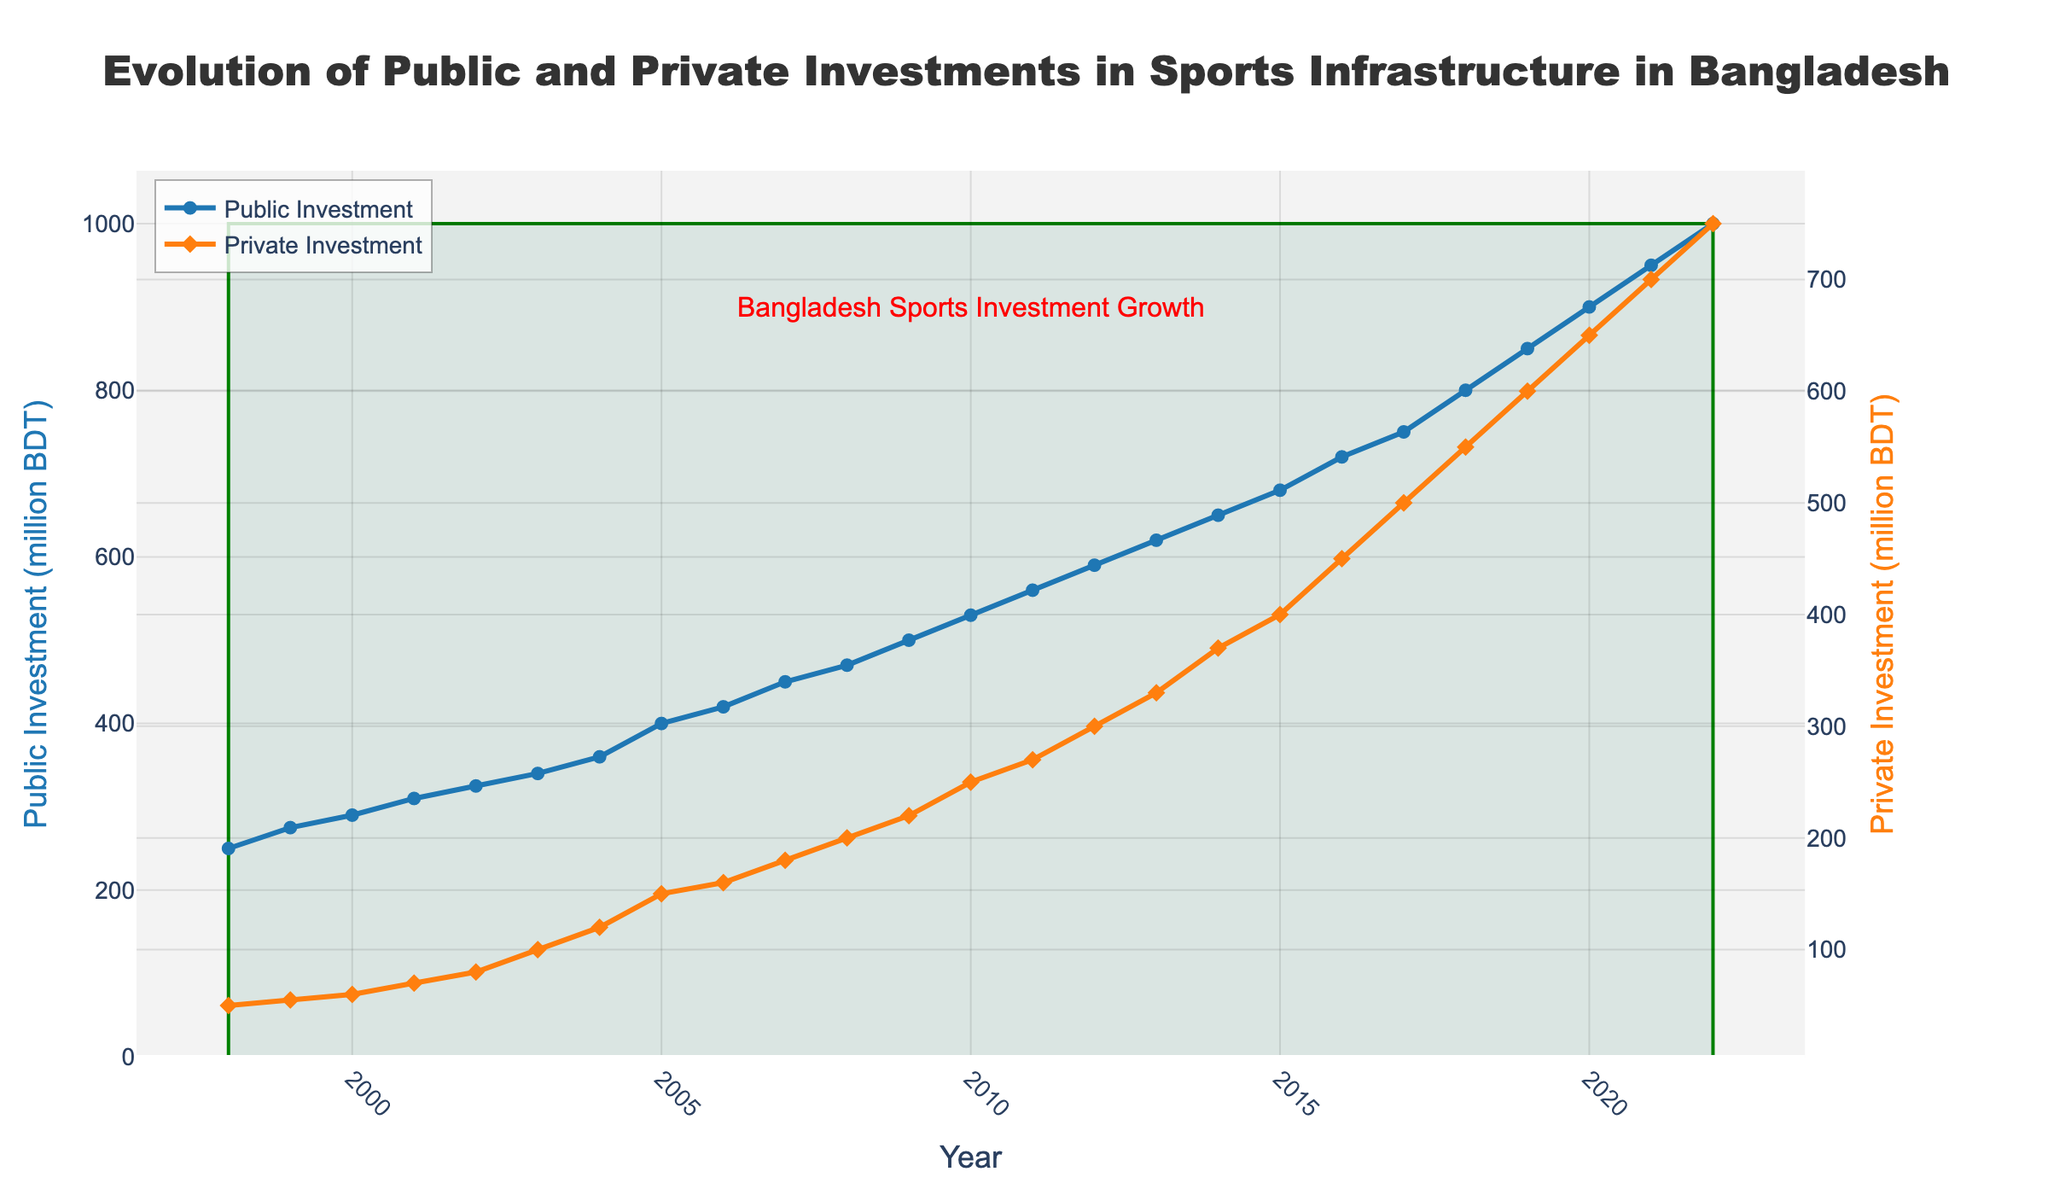what is the title of the plot? The title is prominently displayed at the top of the plot. The text reads "Evolution of Public and Private Investments in Sports Infrastructure in Bangladesh".
Answer: Evolution of Public and Private Investments in Sports Infrastructure in Bangladesh How many years does the x-axis of the plot cover? The x-axis starts at 1998 and ends at 2022. Counting all the years inclusive, it represents a span of 25 years.
Answer: 25 years What is the y-axis range for public investments? The y-axis for public investments starts at 0 million BDT and goes up to 1000 million BDT, as indicated by the axis labels.
Answer: 0 to 1000 million BDT Which type of investment had higher values in 2010? In 2010, the plot shows that public investments reached 530 million BDT, whereas private investments were 250 million BDT, making public investments higher.
Answer: Public Investments What is the overall trend for private investments over the 25 years? The plot shows a general upward trend for private investments, starting at 50 million BDT in 1998 and increasing steadily to 750 million BDT in 2022.
Answer: Upward trend By how much did public investments increase from 1998 to 2022? Public investments in 1998 were 250 million BDT, and by 2022 they had increased to 1000 million BDT. The difference is 1000 - 250 = 750 million BDT.
Answer: 750 million BDT During which year did public investments surpass 500 million BDT? Reviewing the plot, public investments exceed 500 million BDT in the year 2009, when they are shown to reach 500 million BDT.
Answer: 2009 Which year had the highest private investment value? The plot shows that private investments peaked in 2022 at 750 million BDT.
Answer: 2022 What is the ratio of public to private investments in 2022? The public investment is 1000 million BDT, and private investment is 750 million BDT in 2022. The ratio is 1000:750, which simplifies to 4:3.
Answer: 4:3 What significant annotation is included in the plot? An annotation is added near 2010, stating "Bangladesh Sports Investment Growth", highlighting a key point of interest on the graph.
Answer: Bangladesh Sports Investment Growth 